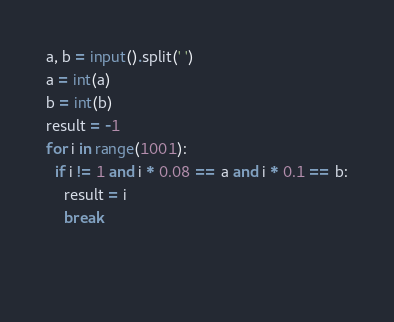<code> <loc_0><loc_0><loc_500><loc_500><_Python_>a, b = input().split(' ')
a = int(a)
b = int(b)
result = -1
for i in range(1001):
  if i != 1 and i * 0.08 == a and i * 0.1 == b:
    result = i
    break
    
  </code> 